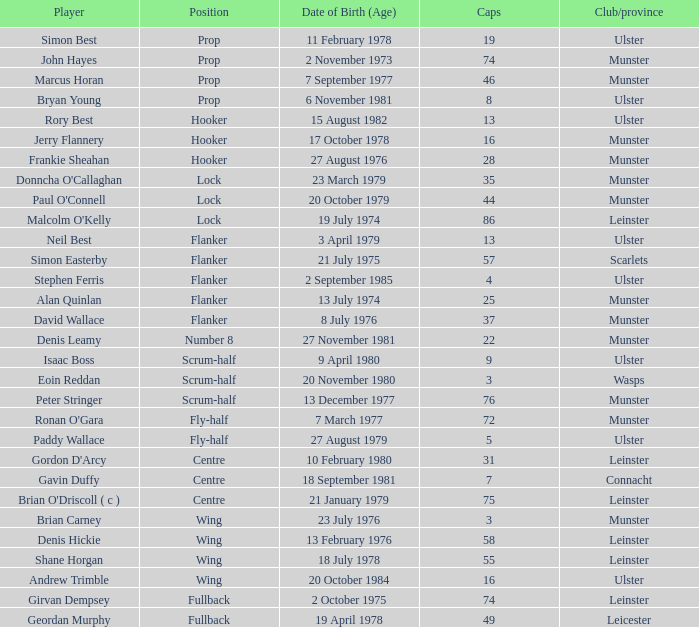Which Ulster player has fewer than 49 caps and plays the wing position? Andrew Trimble. 